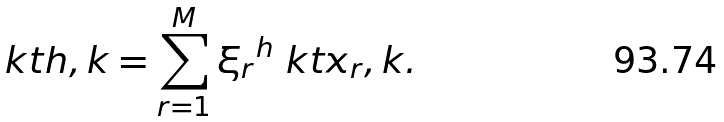<formula> <loc_0><loc_0><loc_500><loc_500>\ k t { h , k } = \sum _ { r = 1 } ^ { M } { \xi _ { r } } ^ { h } \ k t { x _ { r } , k } .</formula> 